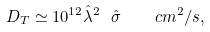<formula> <loc_0><loc_0><loc_500><loc_500>D _ { T } \simeq 1 0 ^ { 1 2 } \hat { \lambda } ^ { 2 } \ \hat { \sigma } \quad c m ^ { 2 } / s ,</formula> 